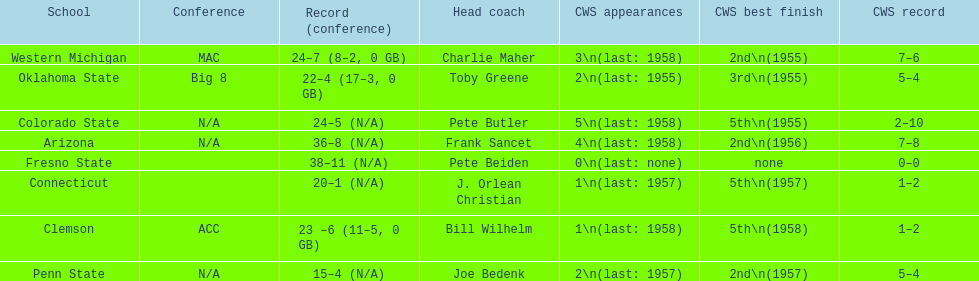Which was the only team with less than 20 wins? Penn State. 